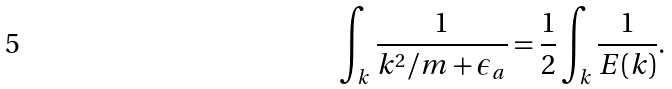<formula> <loc_0><loc_0><loc_500><loc_500>\int _ { k } \frac { 1 } { { k } ^ { 2 } / m + \epsilon _ { a } } = \frac { 1 } { 2 } \int _ { k } \frac { 1 } { E ( { k } ) } .</formula> 